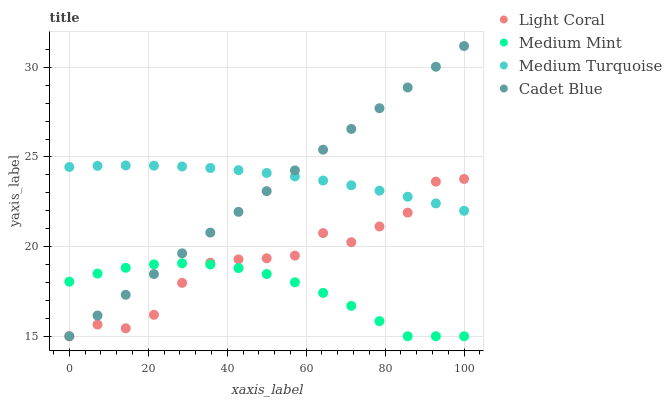Does Medium Mint have the minimum area under the curve?
Answer yes or no. Yes. Does Medium Turquoise have the maximum area under the curve?
Answer yes or no. Yes. Does Cadet Blue have the minimum area under the curve?
Answer yes or no. No. Does Cadet Blue have the maximum area under the curve?
Answer yes or no. No. Is Cadet Blue the smoothest?
Answer yes or no. Yes. Is Light Coral the roughest?
Answer yes or no. Yes. Is Medium Mint the smoothest?
Answer yes or no. No. Is Medium Mint the roughest?
Answer yes or no. No. Does Light Coral have the lowest value?
Answer yes or no. Yes. Does Medium Turquoise have the lowest value?
Answer yes or no. No. Does Cadet Blue have the highest value?
Answer yes or no. Yes. Does Medium Mint have the highest value?
Answer yes or no. No. Is Medium Mint less than Medium Turquoise?
Answer yes or no. Yes. Is Medium Turquoise greater than Medium Mint?
Answer yes or no. Yes. Does Medium Mint intersect Cadet Blue?
Answer yes or no. Yes. Is Medium Mint less than Cadet Blue?
Answer yes or no. No. Is Medium Mint greater than Cadet Blue?
Answer yes or no. No. Does Medium Mint intersect Medium Turquoise?
Answer yes or no. No. 